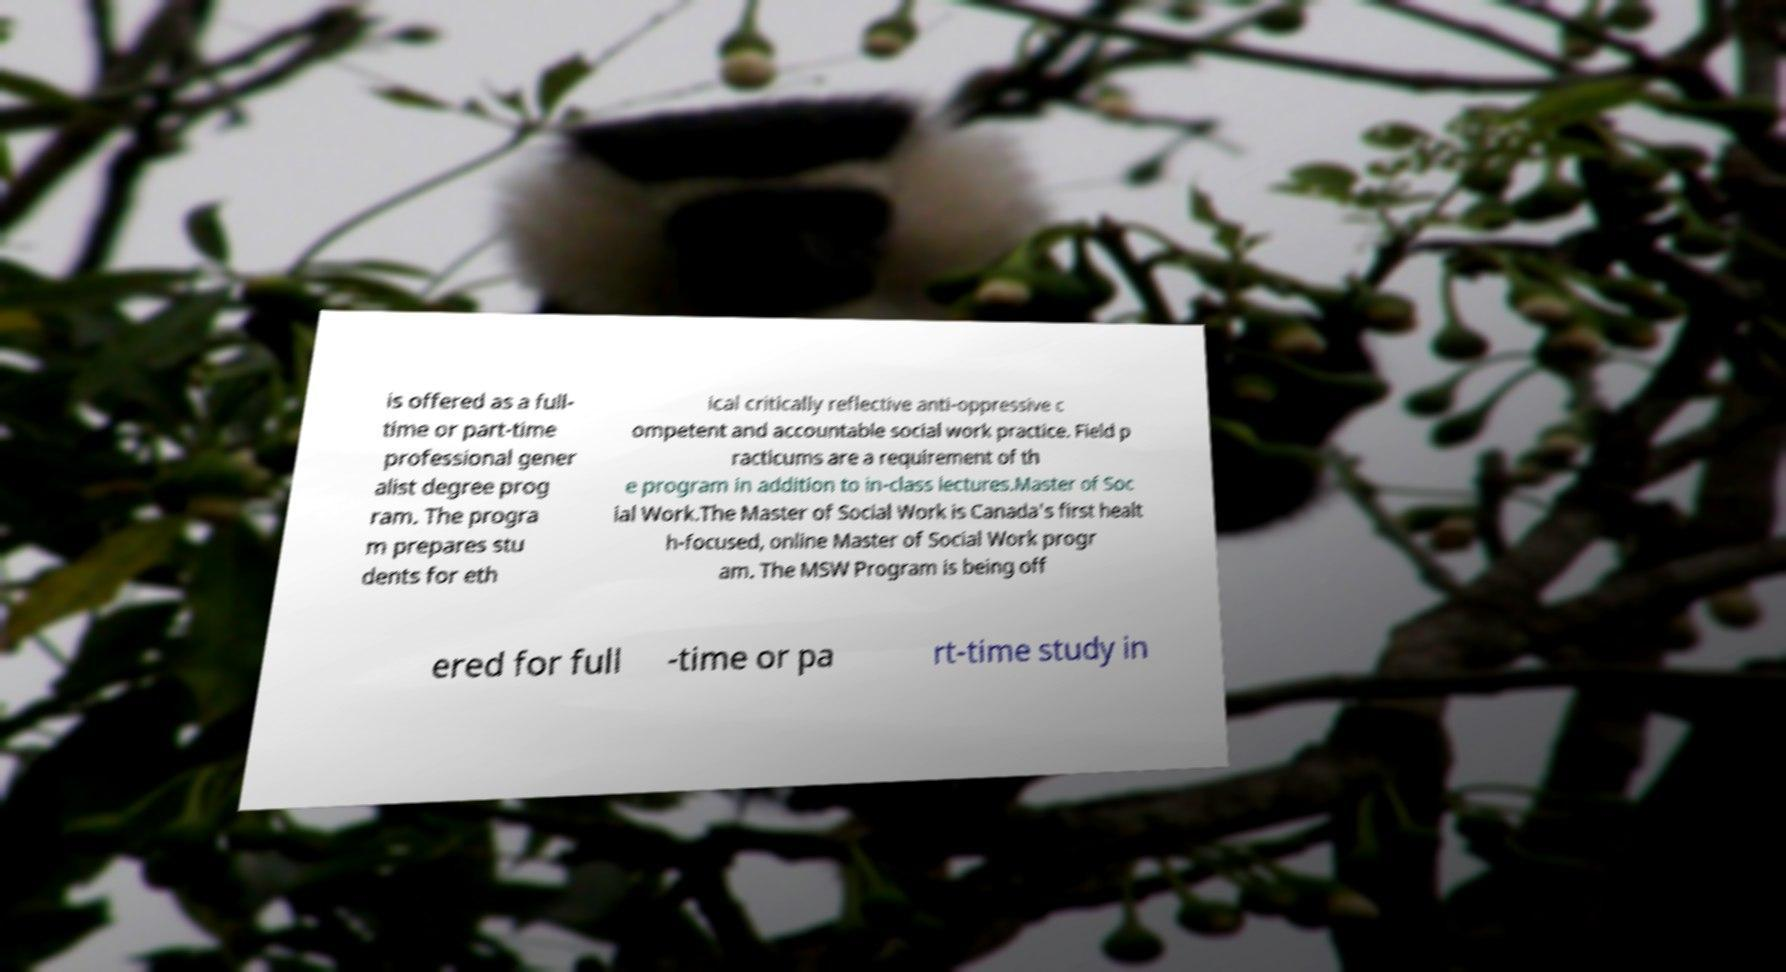Could you assist in decoding the text presented in this image and type it out clearly? is offered as a full- time or part-time professional gener alist degree prog ram. The progra m prepares stu dents for eth ical critically reflective anti-oppressive c ompetent and accountable social work practice. Field p racticums are a requirement of th e program in addition to in-class lectures.Master of Soc ial Work.The Master of Social Work is Canada's first healt h-focused, online Master of Social Work progr am. The MSW Program is being off ered for full -time or pa rt-time study in 